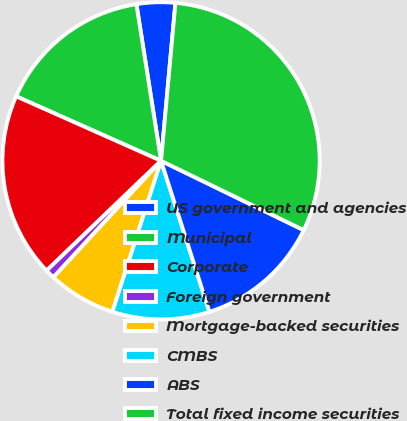<chart> <loc_0><loc_0><loc_500><loc_500><pie_chart><fcel>US government and agencies<fcel>Municipal<fcel>Corporate<fcel>Foreign government<fcel>Mortgage-backed securities<fcel>CMBS<fcel>ABS<fcel>Total fixed income securities<nl><fcel>3.93%<fcel>15.85%<fcel>18.83%<fcel>0.96%<fcel>6.91%<fcel>9.89%<fcel>12.87%<fcel>30.75%<nl></chart> 